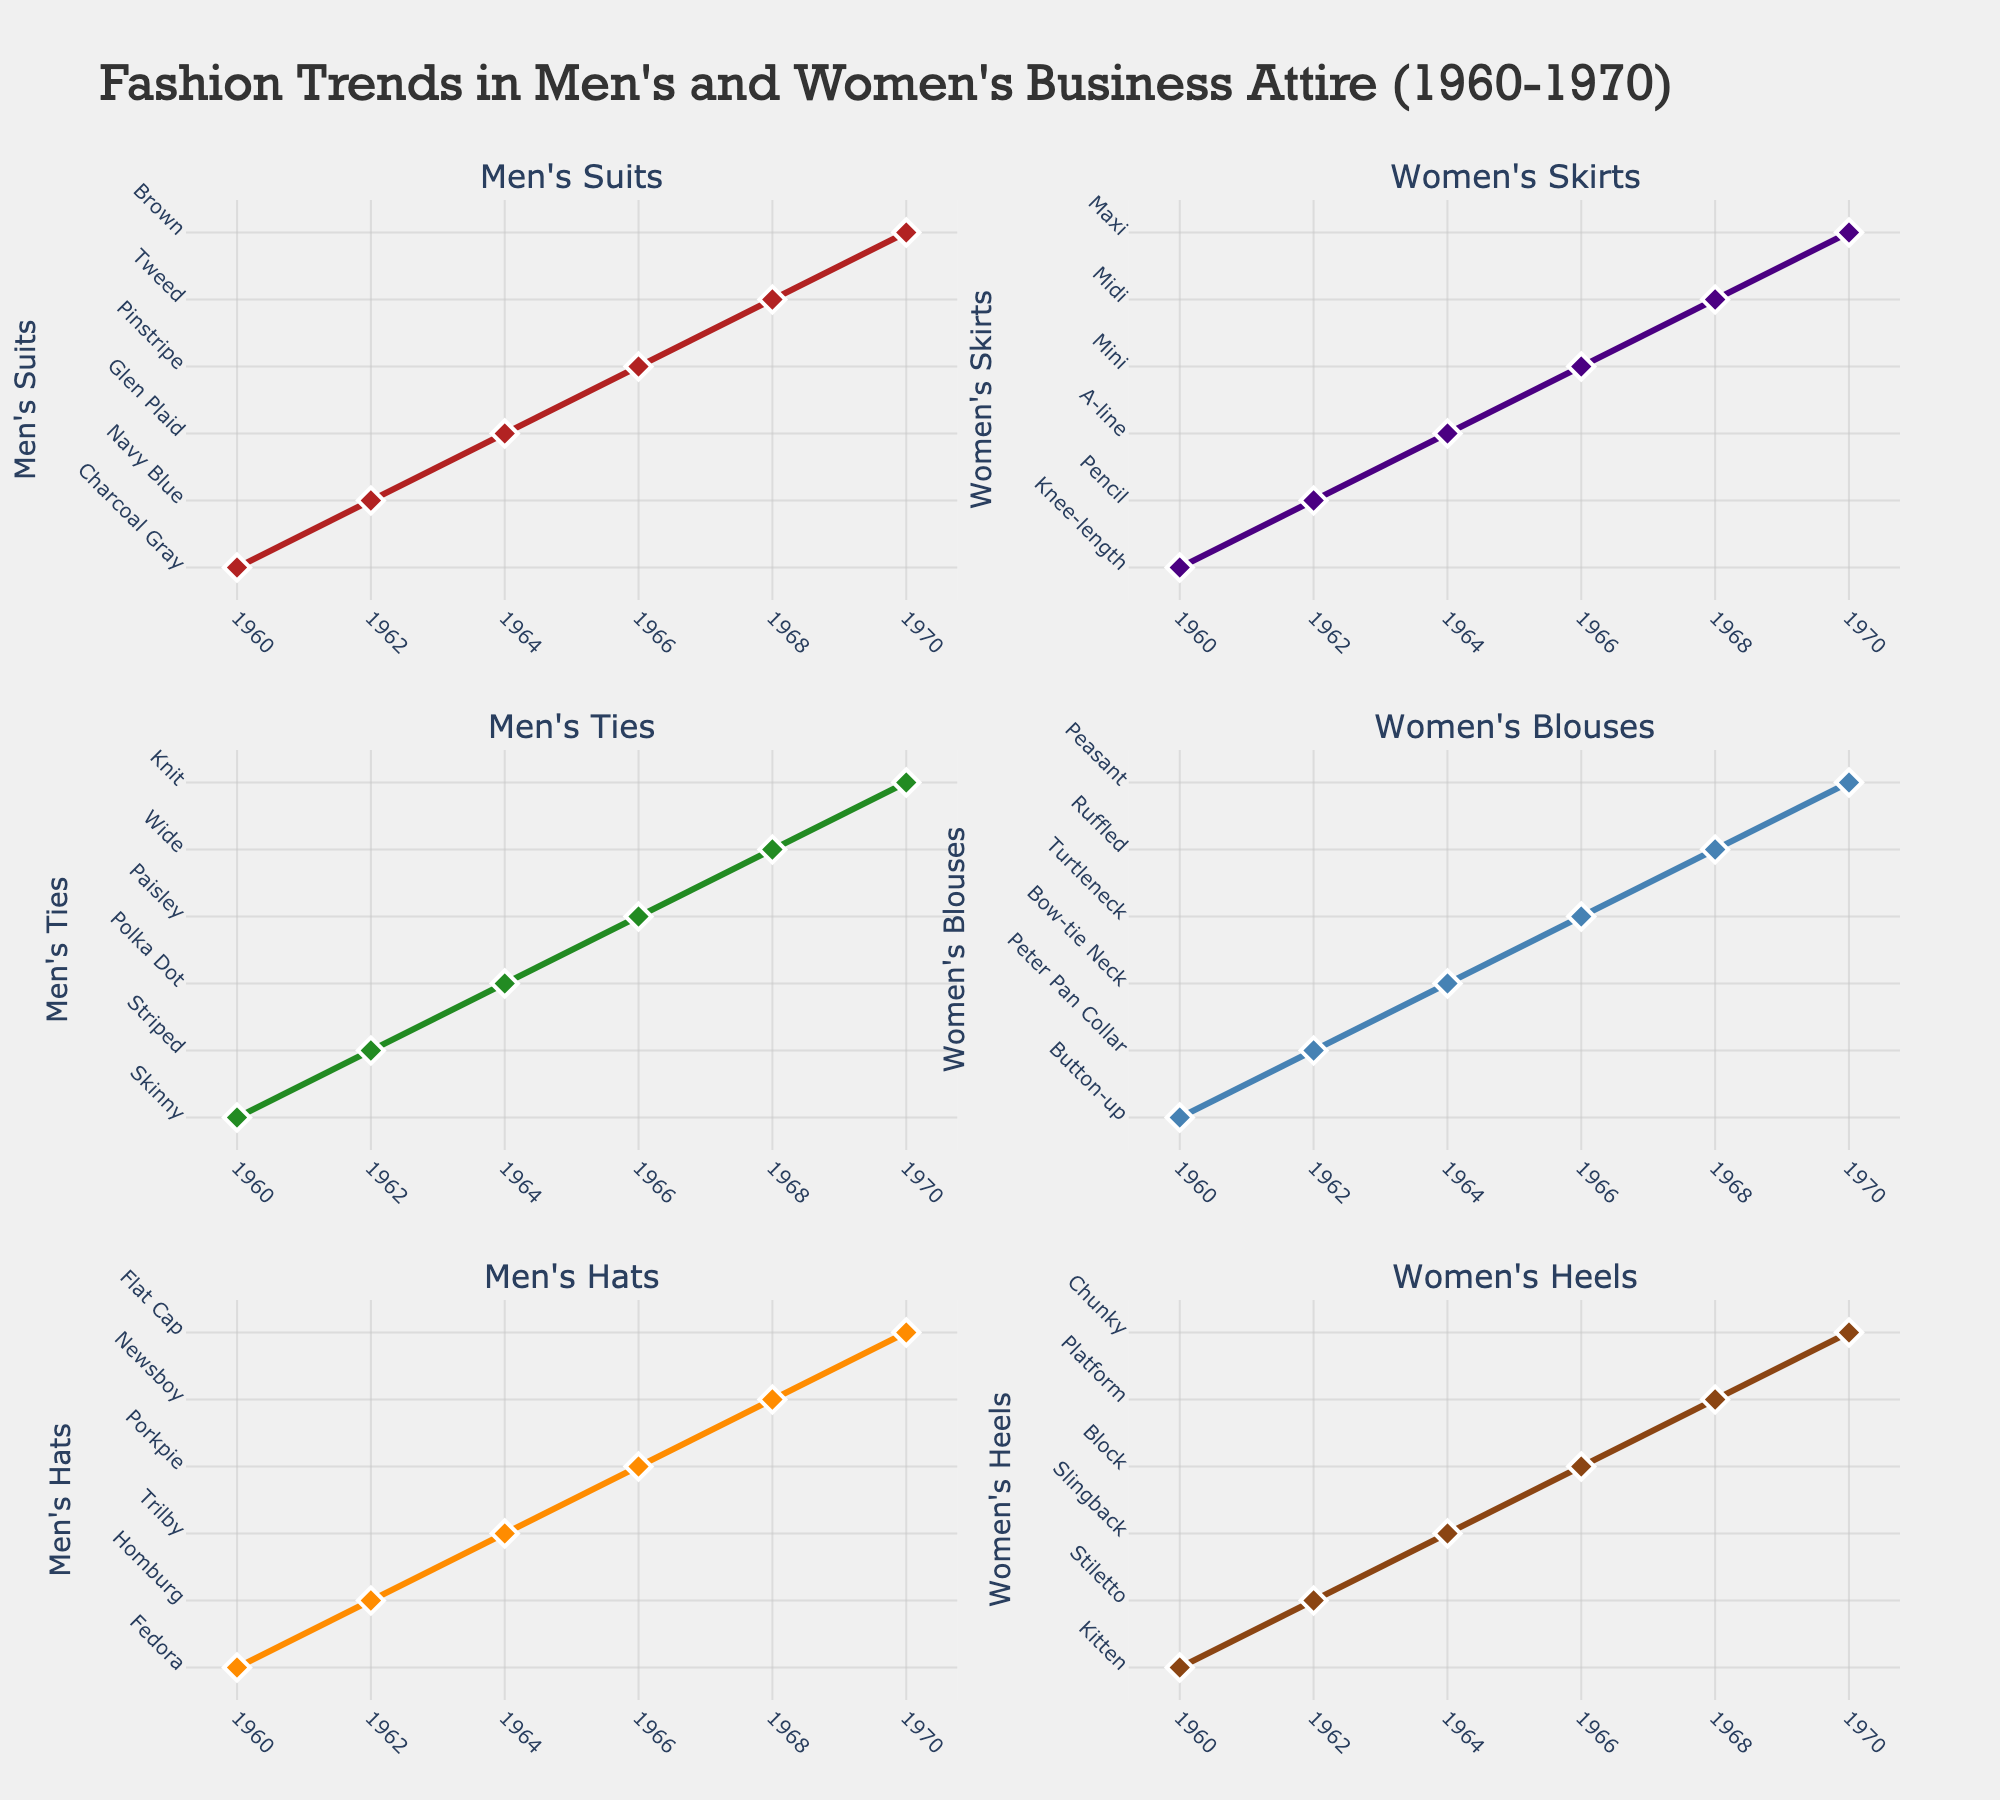What does the title of the figure say? The title is placed at the top-center of the figure and highlights the overall subject being shown in the subplots.
Answer: Trends in Home Care Services and Equipment for the Elderly What years are displayed on the x-axis of each subplot? Observing the x-axes of all subplots, the years range from 2018 to 2022.
Answer: 2018, 2020, 2022 Which country shows the highest adoption of Smart Home Devices in 2022? By looking at the fourth subplot (Smart Home Devices), the line representing Japan reaches the highest point in 2022.
Answer: Japan What is the trend in Home Care Services (% of Elderly) in the United States from 2018 to 2022? Following the blue line representing the United States in the first subplot (Home Care Services), there is a steady increase from 15.2% in 2018 to 20.5% in 2022.
Answer: Increasing How does the percentage usage of Medical Alert Systems in Japan compare between 2018 and 2022? In the third subplot (Medical Alert Systems), the orange line for Japan rises from 15.6% in 2018 to 20.4% in 2022, indicating an increase.
Answer: Increase Which country shows the smallest growth in Mobility Aids market between 2018 and 2022? Observing the fourth subplot (Mobility Aids), the red line representing the United Kingdom shows a growth from 3.0% to 4.3%, which is the smallest increase compared to other countries.
Answer: United Kingdom Compare the adoption of Smart Home Devices in Germany and Canada in 2020. Which country had higher adoption? In the second subplot (Smart Home Devices), the green line for Germany and the purple line for Canada show that Germany had 11.3% adoption, while Canada had 11.7%. Thus, Canada had a slightly higher adoption.
Answer: Canada What is the average percentage of adults using Medical Alert Systems in Germany across all displayed years? Adding the percentages in the third subplot for Germany (11.7% in 2018, 13.8% in 2020, 15.7% in 2022) and dividing by 3 gives an average of (11.7 + 13.8 + 15.7) / 3 = 13.73%.
Answer: 13.73% Which country had the largest increase in Home Care Services (% of Elderly) from 2018 to 2022? In the first subplot, by subtracting the 2018 values from the 2022 values for each country, Japan had the highest increase going from 18.7% to 24.6%, a change of 5.9%.
Answer: Japan 